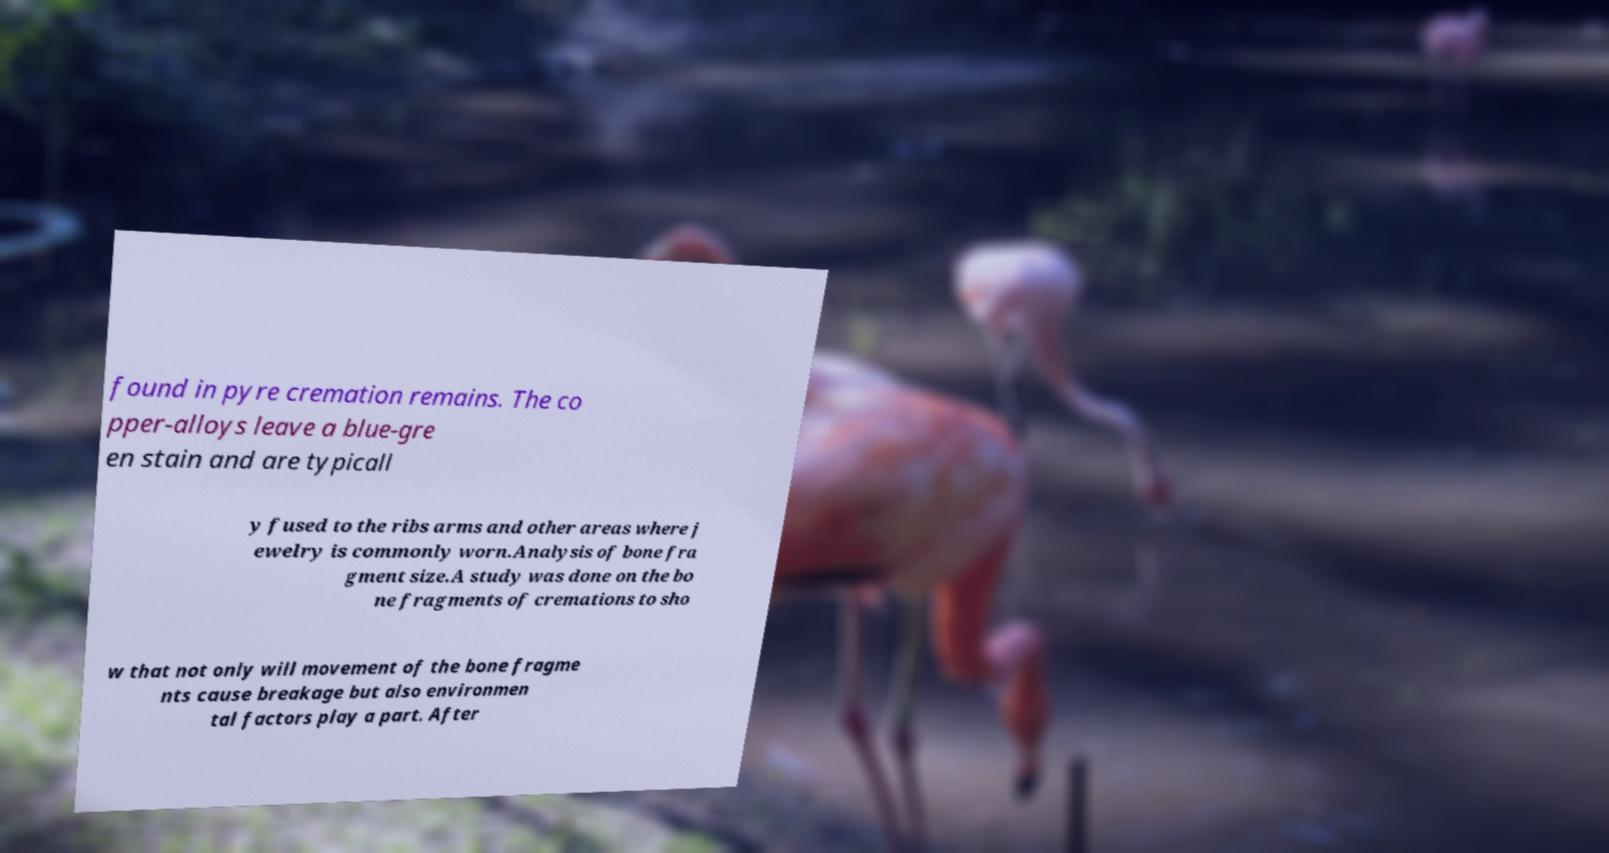Can you accurately transcribe the text from the provided image for me? found in pyre cremation remains. The co pper-alloys leave a blue-gre en stain and are typicall y fused to the ribs arms and other areas where j ewelry is commonly worn.Analysis of bone fra gment size.A study was done on the bo ne fragments of cremations to sho w that not only will movement of the bone fragme nts cause breakage but also environmen tal factors play a part. After 